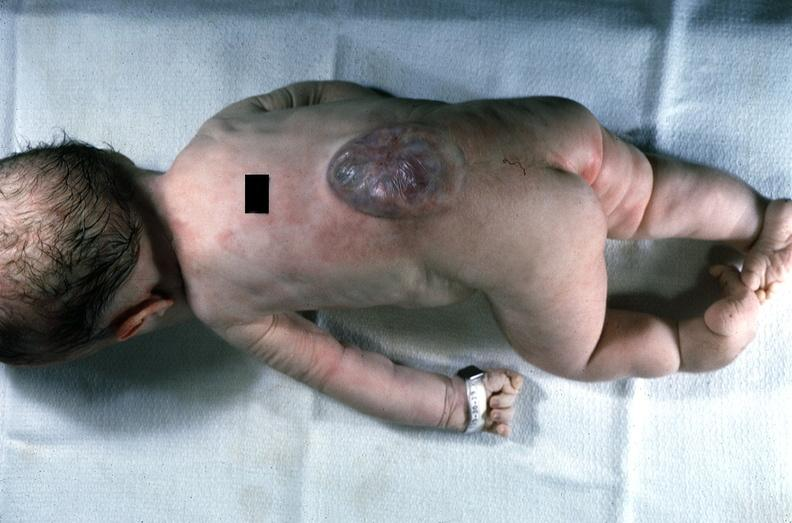what does this image show?
Answer the question using a single word or phrase. Neural tube defect 